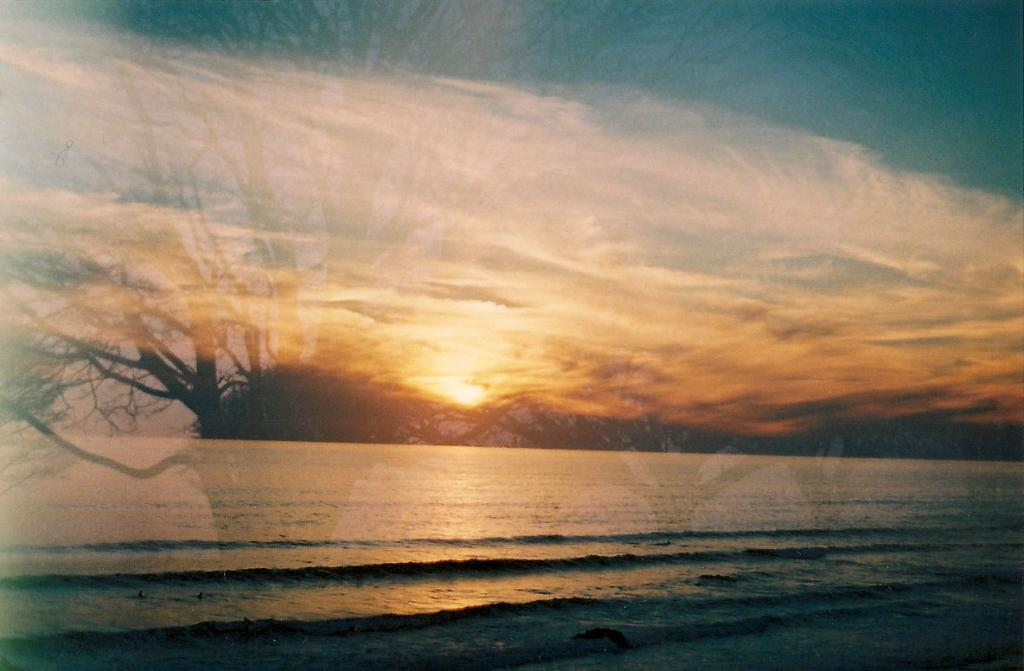What is reflected on the glass in the image? The image contains a reflection of trees on a glass. What is the primary natural element visible in the image? There is water visible in the image. What is a characteristic of the water in the image? The water has tides. What can be seen in the sky in the image? The sky is visible in the image, and there are clouds and the sun visible. What type of book is floating on the water in the image? There is no book present in the image; it only features a reflection of trees on a glass, water with tides, and a sky with clouds and the sun. 